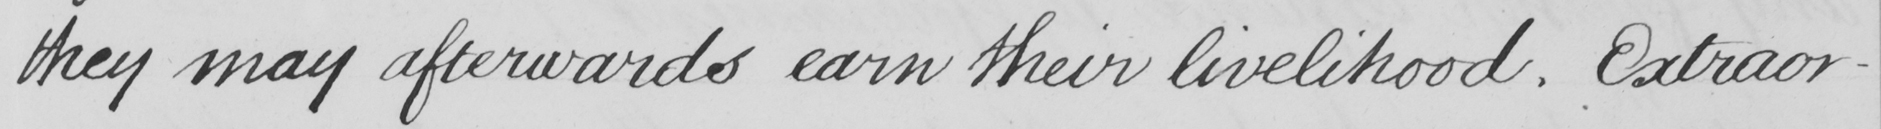Transcribe the text shown in this historical manuscript line. they may afterwards earn their livelihood . Extraor- 